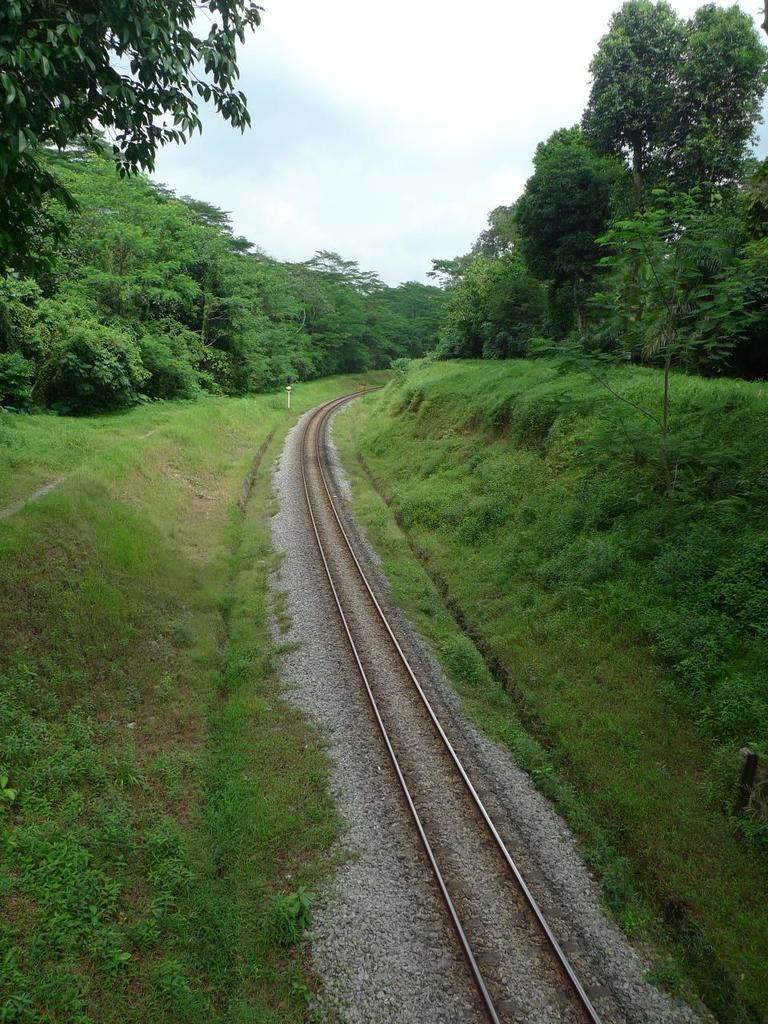What type of vegetation is present in the image? There are trees and grass in the image. What else can be seen in the image besides vegetation? There are other objects in the image. What is located at the bottom of the image? There is a railway track at the bottom of the image. Are there any plants near the railway track? Yes, there are plants near the railway track. What is visible at the top of the image? The sky is visible at the top of the image. Can you tell me how many bats are hanging from the trees in the image? There are no bats present in the image; only trees, grass, and other objects are visible. What type of power source is used for the railway track in the image? The image does not provide information about the power source for the railway track. 